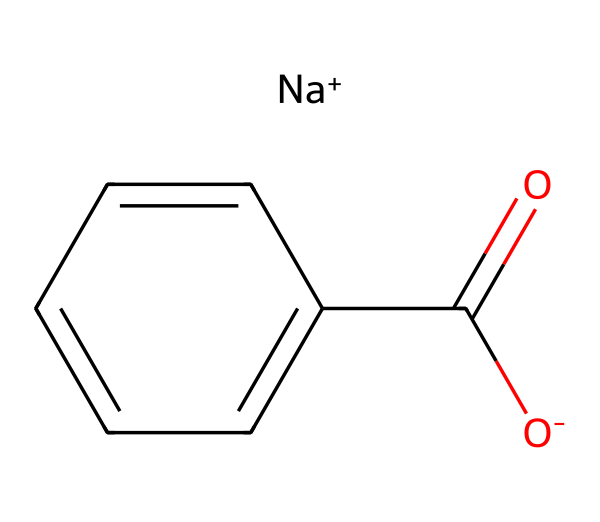What is the main functional group present in this chemical? The main functional group is the carboxyl group (-COOH), which is indicated by the carbon atom bonded to both an oxygen atom with a double bond and a hydroxyl group (-OH). In the SMILES representation, it is shown as C(=O)O.
Answer: carboxyl How many carbon atoms are present in this compound? By analyzing the structure, there are seven carbon atoms. One carbon is part of the carboxyl group, and the other six are part of the benzene ring structure.
Answer: seven What is the role of sodium in this compound? Sodium acts as a counterion to the carboxylate part of the compound, balancing the negative charge present on the oxygen (O-) in the carboxylate group. The sodium ion helps in maintaining the solubility of sodium benzoate in aqueous solutions.
Answer: counterion What type of bonding is primarily observed in sodium benzoate? The structure features ionic bonding between the sodium ion and the carboxylate ion (O-) and covalent bonding within the benzene ring connecting the carbon atoms and between carbon and oxygen.
Answer: ionic and covalent Is sodium benzoate considered a weak or strong preservative? Sodium benzoate is considered a weak preservative due to its effectiveness being pH-dependent, primarily functioning at a low pH where it exists in a more undissociated form to inhibit microbial growth.
Answer: weak 